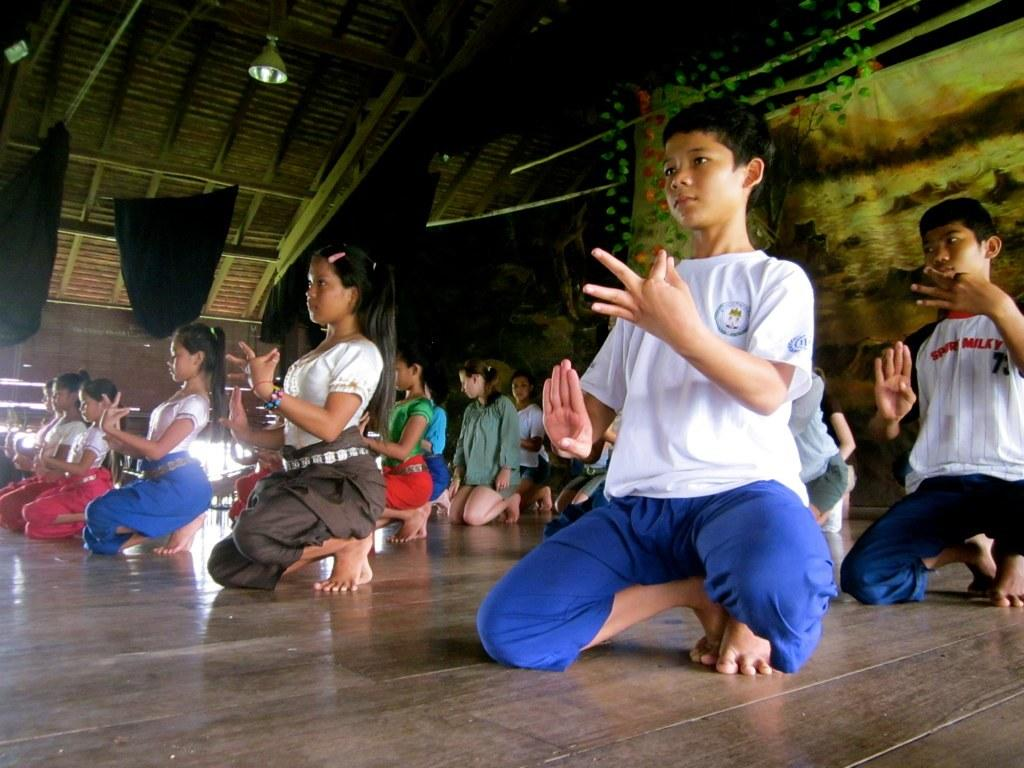What are the people in the image doing? The people in the image are doing exercise. What are the people wearing while exercising? The people are wearing multi-color dresses. Can you describe any background elements in the image? There is a banner hanged to a wooden stick and a light visible in the background. How does the family feel about the amusement park in the image? There is no family or amusement park present in the image; it features a group of people doing exercise. 